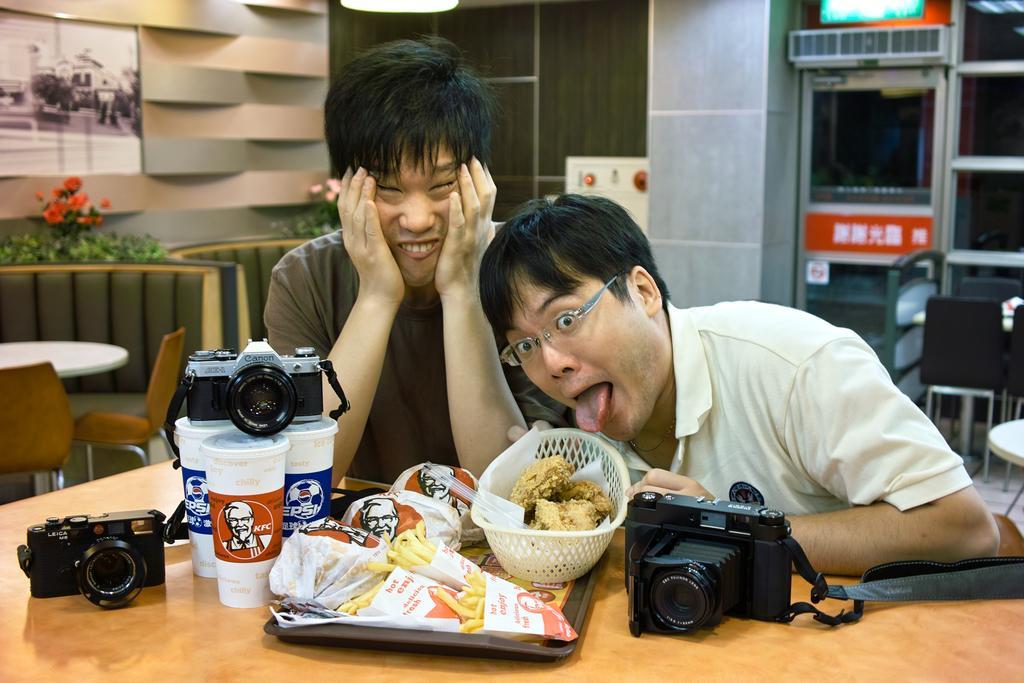In one or two sentences, can you explain what this image depicts? In this image there is a table, on that table there are cameras, glasses and a tray, in that tree there is food item, behind the table there are two persons sitting on chairs, in the background there is a table chairs, plants and a pillar. 